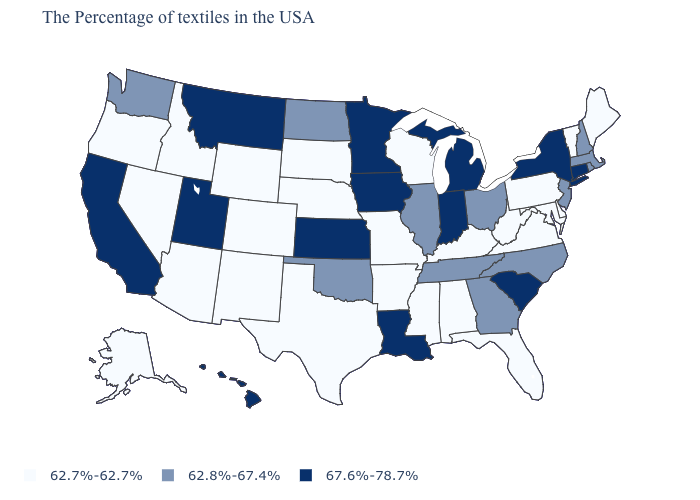Which states hav the highest value in the South?
Write a very short answer. South Carolina, Louisiana. Among the states that border Idaho , which have the lowest value?
Be succinct. Wyoming, Nevada, Oregon. Name the states that have a value in the range 62.7%-62.7%?
Keep it brief. Maine, Vermont, Delaware, Maryland, Pennsylvania, Virginia, West Virginia, Florida, Kentucky, Alabama, Wisconsin, Mississippi, Missouri, Arkansas, Nebraska, Texas, South Dakota, Wyoming, Colorado, New Mexico, Arizona, Idaho, Nevada, Oregon, Alaska. What is the value of Louisiana?
Be succinct. 67.6%-78.7%. How many symbols are there in the legend?
Short answer required. 3. Name the states that have a value in the range 62.7%-62.7%?
Be succinct. Maine, Vermont, Delaware, Maryland, Pennsylvania, Virginia, West Virginia, Florida, Kentucky, Alabama, Wisconsin, Mississippi, Missouri, Arkansas, Nebraska, Texas, South Dakota, Wyoming, Colorado, New Mexico, Arizona, Idaho, Nevada, Oregon, Alaska. Among the states that border Texas , does New Mexico have the lowest value?
Quick response, please. Yes. Does North Dakota have a lower value than New York?
Short answer required. Yes. Name the states that have a value in the range 62.8%-67.4%?
Give a very brief answer. Massachusetts, Rhode Island, New Hampshire, New Jersey, North Carolina, Ohio, Georgia, Tennessee, Illinois, Oklahoma, North Dakota, Washington. What is the lowest value in the South?
Quick response, please. 62.7%-62.7%. What is the value of Nevada?
Concise answer only. 62.7%-62.7%. What is the value of Tennessee?
Quick response, please. 62.8%-67.4%. Name the states that have a value in the range 62.8%-67.4%?
Short answer required. Massachusetts, Rhode Island, New Hampshire, New Jersey, North Carolina, Ohio, Georgia, Tennessee, Illinois, Oklahoma, North Dakota, Washington. What is the value of Washington?
Keep it brief. 62.8%-67.4%. What is the highest value in the Northeast ?
Quick response, please. 67.6%-78.7%. 